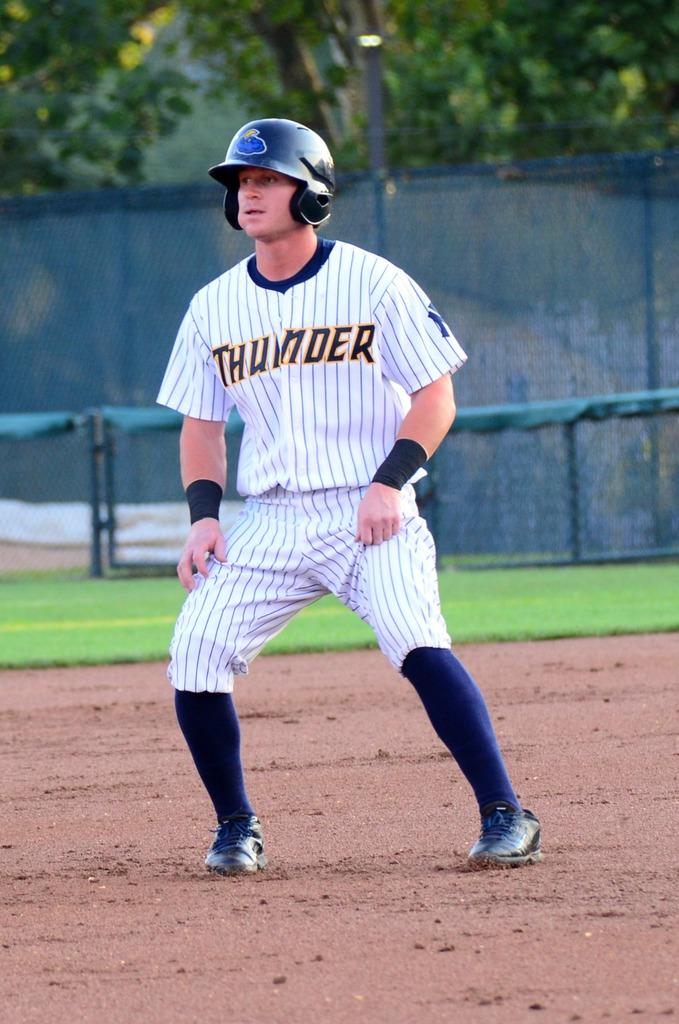<image>
Summarize the visual content of the image. A baseball player with blue socks in a pin striped jersey that reads THUNDER on the front 